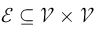Convert formula to latex. <formula><loc_0><loc_0><loc_500><loc_500>\mathcal { E } \subseteq \mathcal { V } \times \mathcal { V }</formula> 